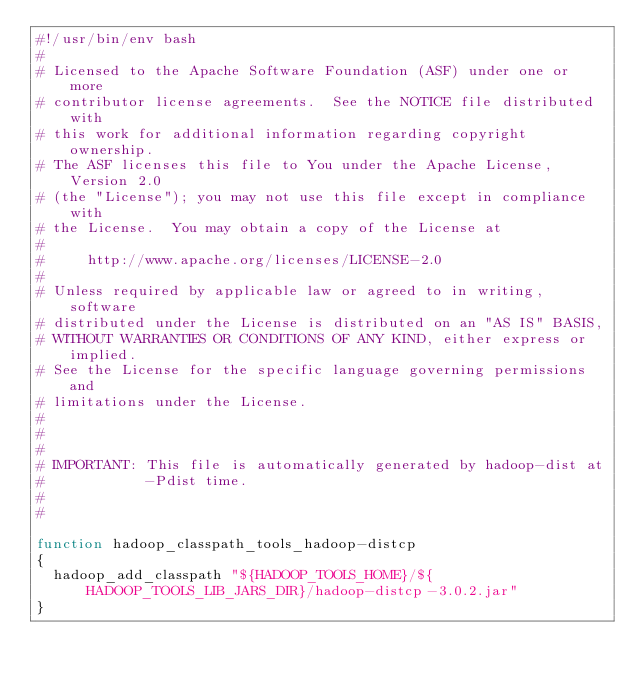Convert code to text. <code><loc_0><loc_0><loc_500><loc_500><_Bash_>#!/usr/bin/env bash
#
# Licensed to the Apache Software Foundation (ASF) under one or more
# contributor license agreements.  See the NOTICE file distributed with
# this work for additional information regarding copyright ownership.
# The ASF licenses this file to You under the Apache License, Version 2.0
# (the "License"); you may not use this file except in compliance with
# the License.  You may obtain a copy of the License at
#
#     http://www.apache.org/licenses/LICENSE-2.0
#
# Unless required by applicable law or agreed to in writing, software
# distributed under the License is distributed on an "AS IS" BASIS,
# WITHOUT WARRANTIES OR CONDITIONS OF ANY KIND, either express or implied.
# See the License for the specific language governing permissions and
# limitations under the License.
#
#
#
# IMPORTANT: This file is automatically generated by hadoop-dist at
#            -Pdist time.
#
#

function hadoop_classpath_tools_hadoop-distcp
{
  hadoop_add_classpath "${HADOOP_TOOLS_HOME}/${HADOOP_TOOLS_LIB_JARS_DIR}/hadoop-distcp-3.0.2.jar"
}

</code> 